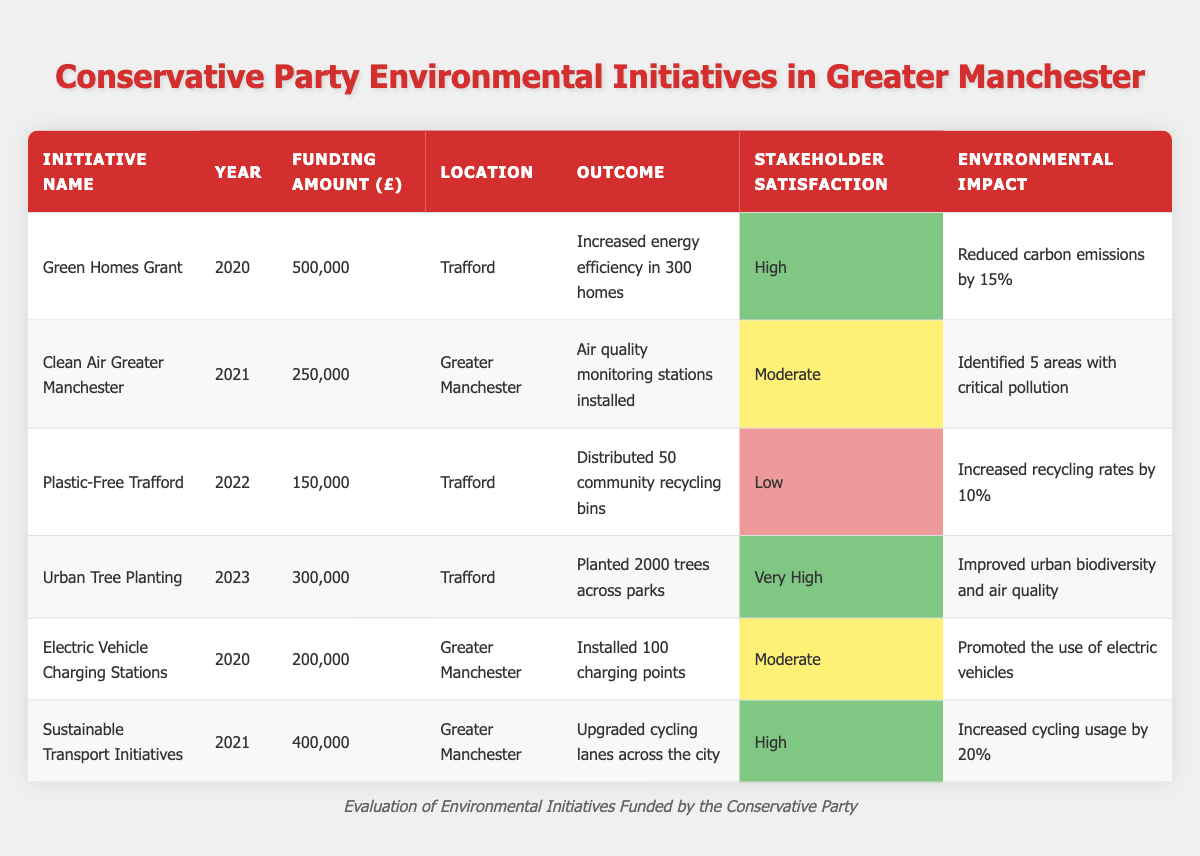What was the funding amount for the Green Homes Grant initiative? The table shows that the funding amount for the Green Homes Grant is listed in the corresponding row under the Funding Amount column. The specific figure is 500,000.
Answer: 500,000 Which initiative had the highest stakeholder satisfaction? Reviewing the Stakeholder Satisfaction column, the highest level of satisfaction is marked as "Very High," which is associated with the Urban Tree Planting initiative from 2023.
Answer: Urban Tree Planting How many trees were planted in the Urban Tree Planting initiative? The outcome for the Urban Tree Planting initiative indicates that 2,000 trees were planted across parks, directly referring to that specific row in the table.
Answer: 2,000 What is the total funding amount for initiatives located in Trafford? To calculate this, we add the funding amounts from the initiatives located in Trafford, which are: Green Homes Grant (500,000) + Plastic-Free Trafford (150,000) + Urban Tree Planting (300,000) = 950,000.
Answer: 950,000 Did any initiative identify areas with critical pollution? Looking at the table, the Clean Air Greater Manchester initiative in 2021 specifically mentions identifying 5 areas with critical pollution, confirming that this initiative did indeed report such findings.
Answer: Yes Was the stakeholder satisfaction for the Plastic-Free Trafford initiative high? The table indicates that the stakeholder satisfaction for the Plastic-Free Trafford initiative is categorized as "Low." Therefore, the answer to whether it was high is no.
Answer: No What proportion of the initiatives had a moderate level of stakeholder satisfaction? There are 6 initiatives in total, and 2 of them (Clean Air Greater Manchester and Electric Vehicle Charging Stations) have a moderate satisfaction level. The proportion is thus 2 out of 6, which can be simplified to 1/3 (or about 33.33%).
Answer: 1/3 How much funding was allocated to initiatives that improved air quality? The initiatives that specifically mention improving air quality are Urban Tree Planting (300,000) and Clean Air Greater Manchester (250,000). Adding these two amounts together gives 300,000 + 250,000 = 550,000.
Answer: 550,000 Which year had the least funding allocated to environmental initiatives? Reviewing the Funding Amount column year by year, we find that the least funding is assigned to the Plastic-Free Trafford initiative in 2022, with only 150,000 allocated for that year compared to other years.
Answer: 2022 